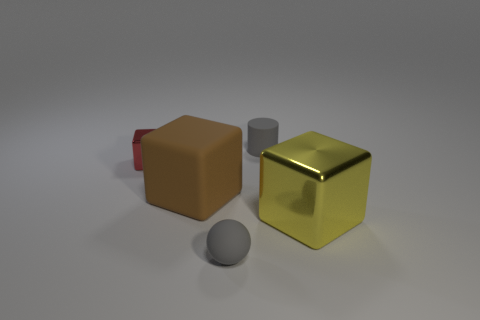There is a sphere that is made of the same material as the big brown block; what color is it?
Your response must be concise. Gray. Are there fewer yellow metallic objects in front of the gray sphere than big matte spheres?
Your answer should be very brief. No. There is a block in front of the brown thing in front of the small object on the left side of the gray rubber ball; what is its size?
Make the answer very short. Large. Do the tiny thing that is in front of the large yellow shiny object and the large yellow block have the same material?
Your answer should be compact. No. What material is the small thing that is the same color as the tiny matte ball?
Offer a terse response. Rubber. Is there anything else that has the same shape as the tiny red shiny object?
Provide a succinct answer. Yes. How many things are tiny yellow metallic spheres or big things?
Offer a terse response. 2. What size is the red metallic thing that is the same shape as the large yellow shiny object?
Make the answer very short. Small. What number of other objects are there of the same color as the large metallic cube?
Offer a very short reply. 0. What number of cylinders are either big yellow objects or large objects?
Keep it short and to the point. 0. 